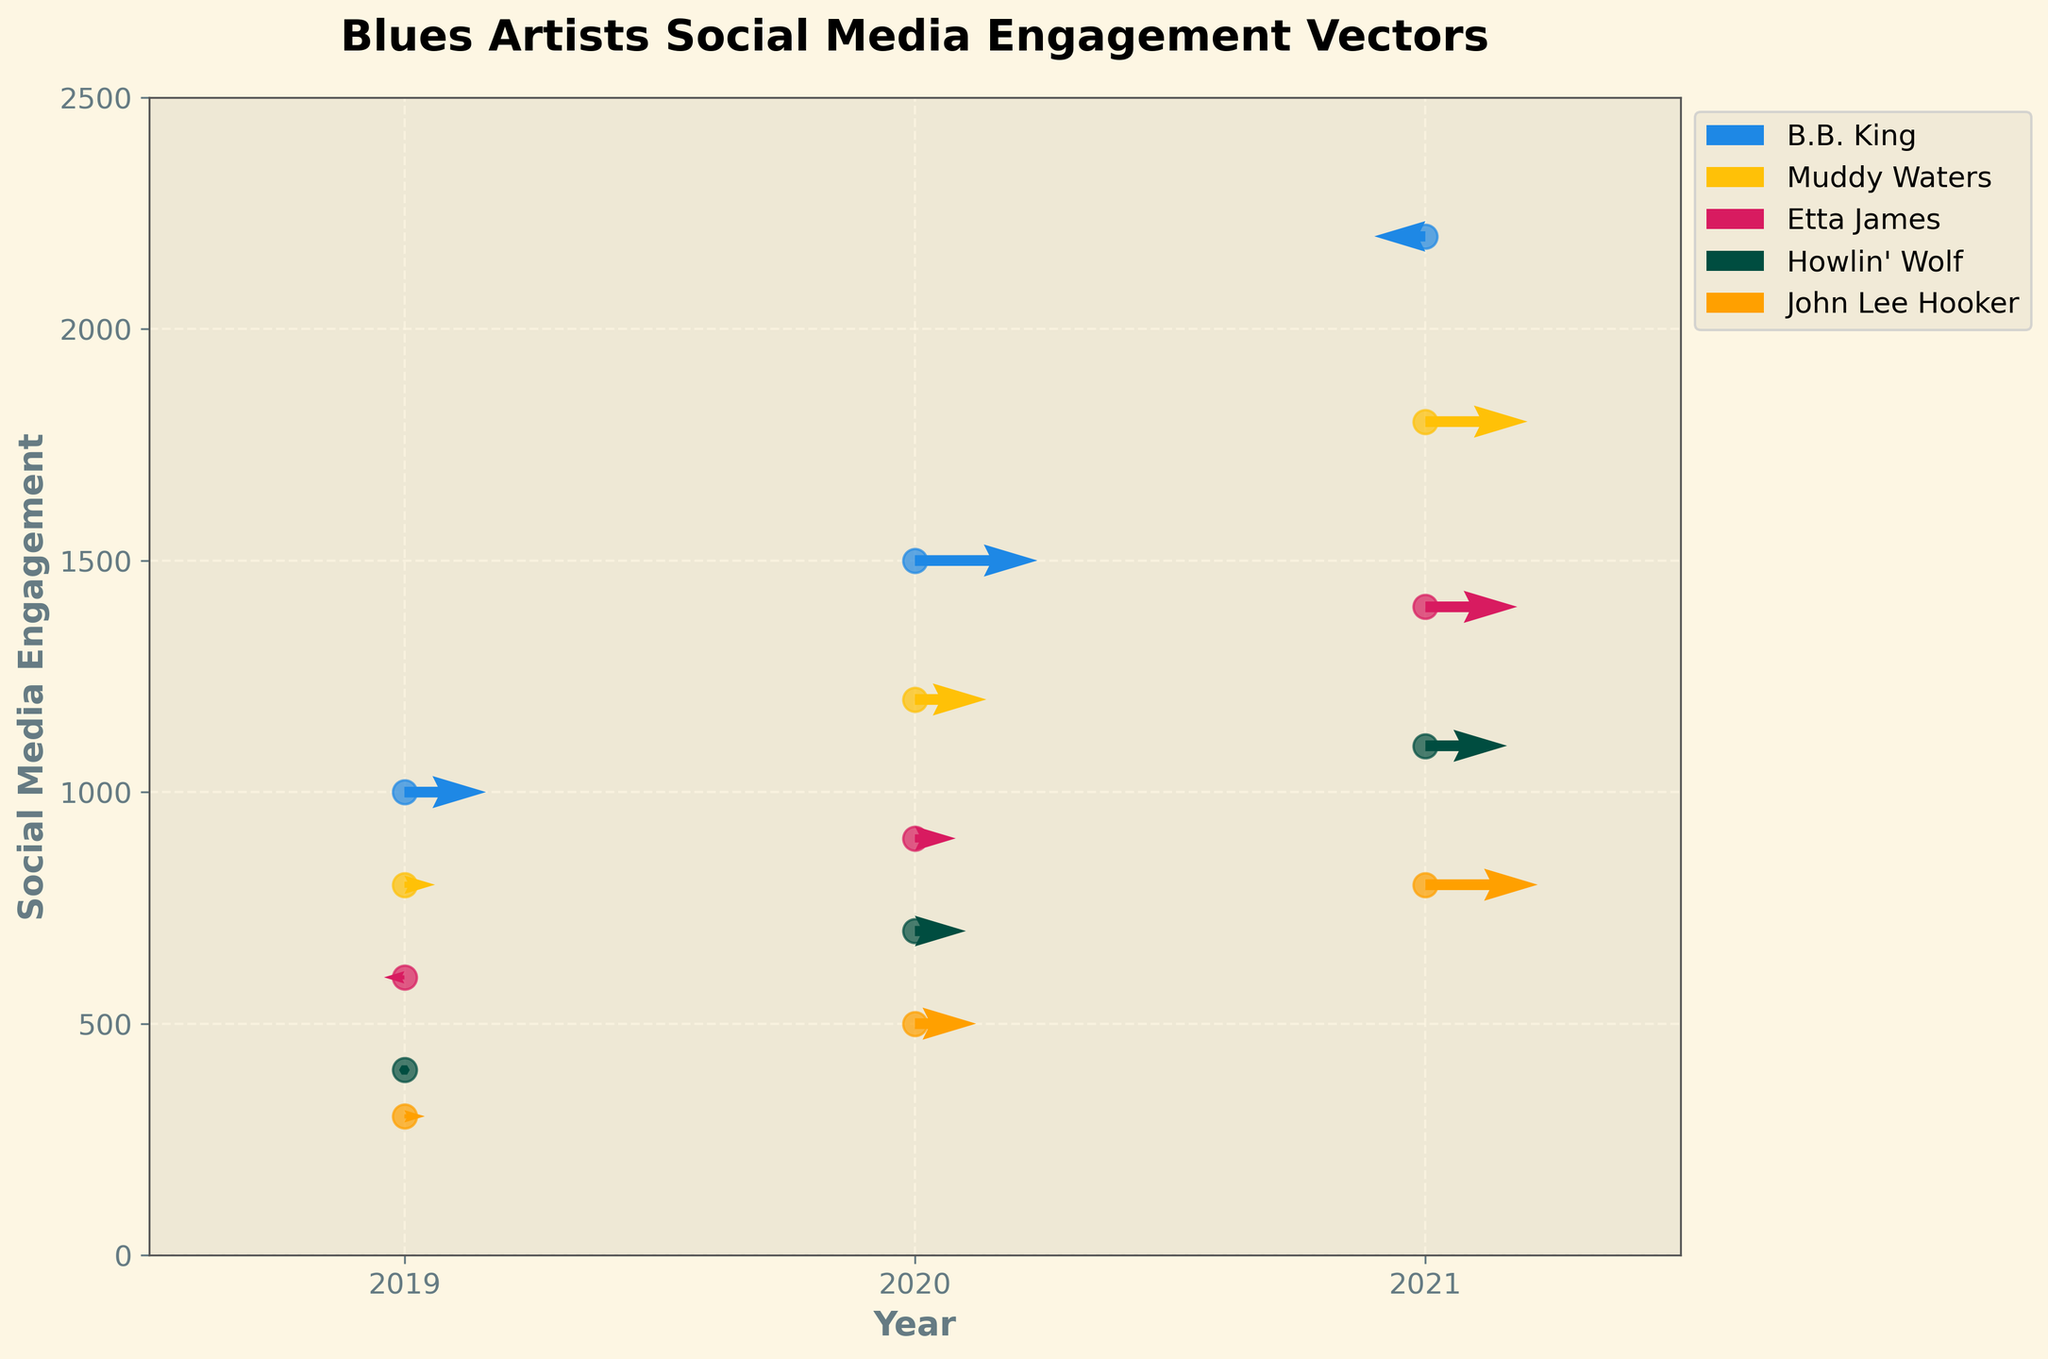What's the title of the figure? The title is often found at the top of the figure and explains the main subject or focus.
Answer: Blues Artists Social Media Engagement Vectors What are the x-axis and y-axis labels? The axis labels are usually found alongside the respective axes and describe what each axis represents in the plot.
Answer: x-axis: Year, y-axis: Social Media Engagement How many data points are shown for each artist? Each arrow and corresponding circle in the plot represents a data point for an artist. By counting these, we can determine how many data points are present for each artist.
Answer: 3 How did B.B. King's social media engagement change between 2020 and 2021? To understand the change, we need to analyze the vectors representing social media engagement from 2020 to 2021 for B.B. King. Checking the direction and magnitude of the arrows can show if there's an increase or decrease.
Answer: Decreased Which artist has the highest social media engagement in 2021? By comparing the y-axis values of the data points for 2021, we can identify the artist with the highest engagement value.
Answer: B.B. King How does Muddy Waters' engagement trend from 2019 to 2021 differ from Etta James'? Compare the direction and length of the vectors for both artists over the given years to understand their respective engagement trends. Muddy Waters shows a steady rise in both factors each year, whereas Etta James shows consistent growth.
Answer: Muddy Waters exhibits a steady but moderate increase, whereas Etta James shows a more accelerated increase What is the average social media engagement in 2020 for all artists? To find the average, sum the engagement values of all artists for the year 2020 and divide by the number of artists.
Answer: (1500 + 1200 + 900 + 700 + 500) / 5 = 960 Between Muddy Waters and Howlin' Wolf, who had a more significant improvement in engagement from 2019 to 2020? Compare the lengths of the vectors pointing from 2019 to 2020 for Muddy Waters and Howlin' Wolf to see which is longer, indicating a more significant change.
Answer: Howlin' Wolf What does the direction of the arrows in the plot indicate? The direction of the arrows represents the changes in social media engagement over time, pointing from the year represented by the base to the year represented by the tip.
Answer: Changes in social media engagement over time Which artist had a decrease in engagement in any given year, and when was it? Look for any arrows pointing downward to determine if any artist experienced a drop in engagement in a specific year. John Lee Hooker had a decrease between 2019 and 2020.
Answer: John Lee Hooker in 2019 